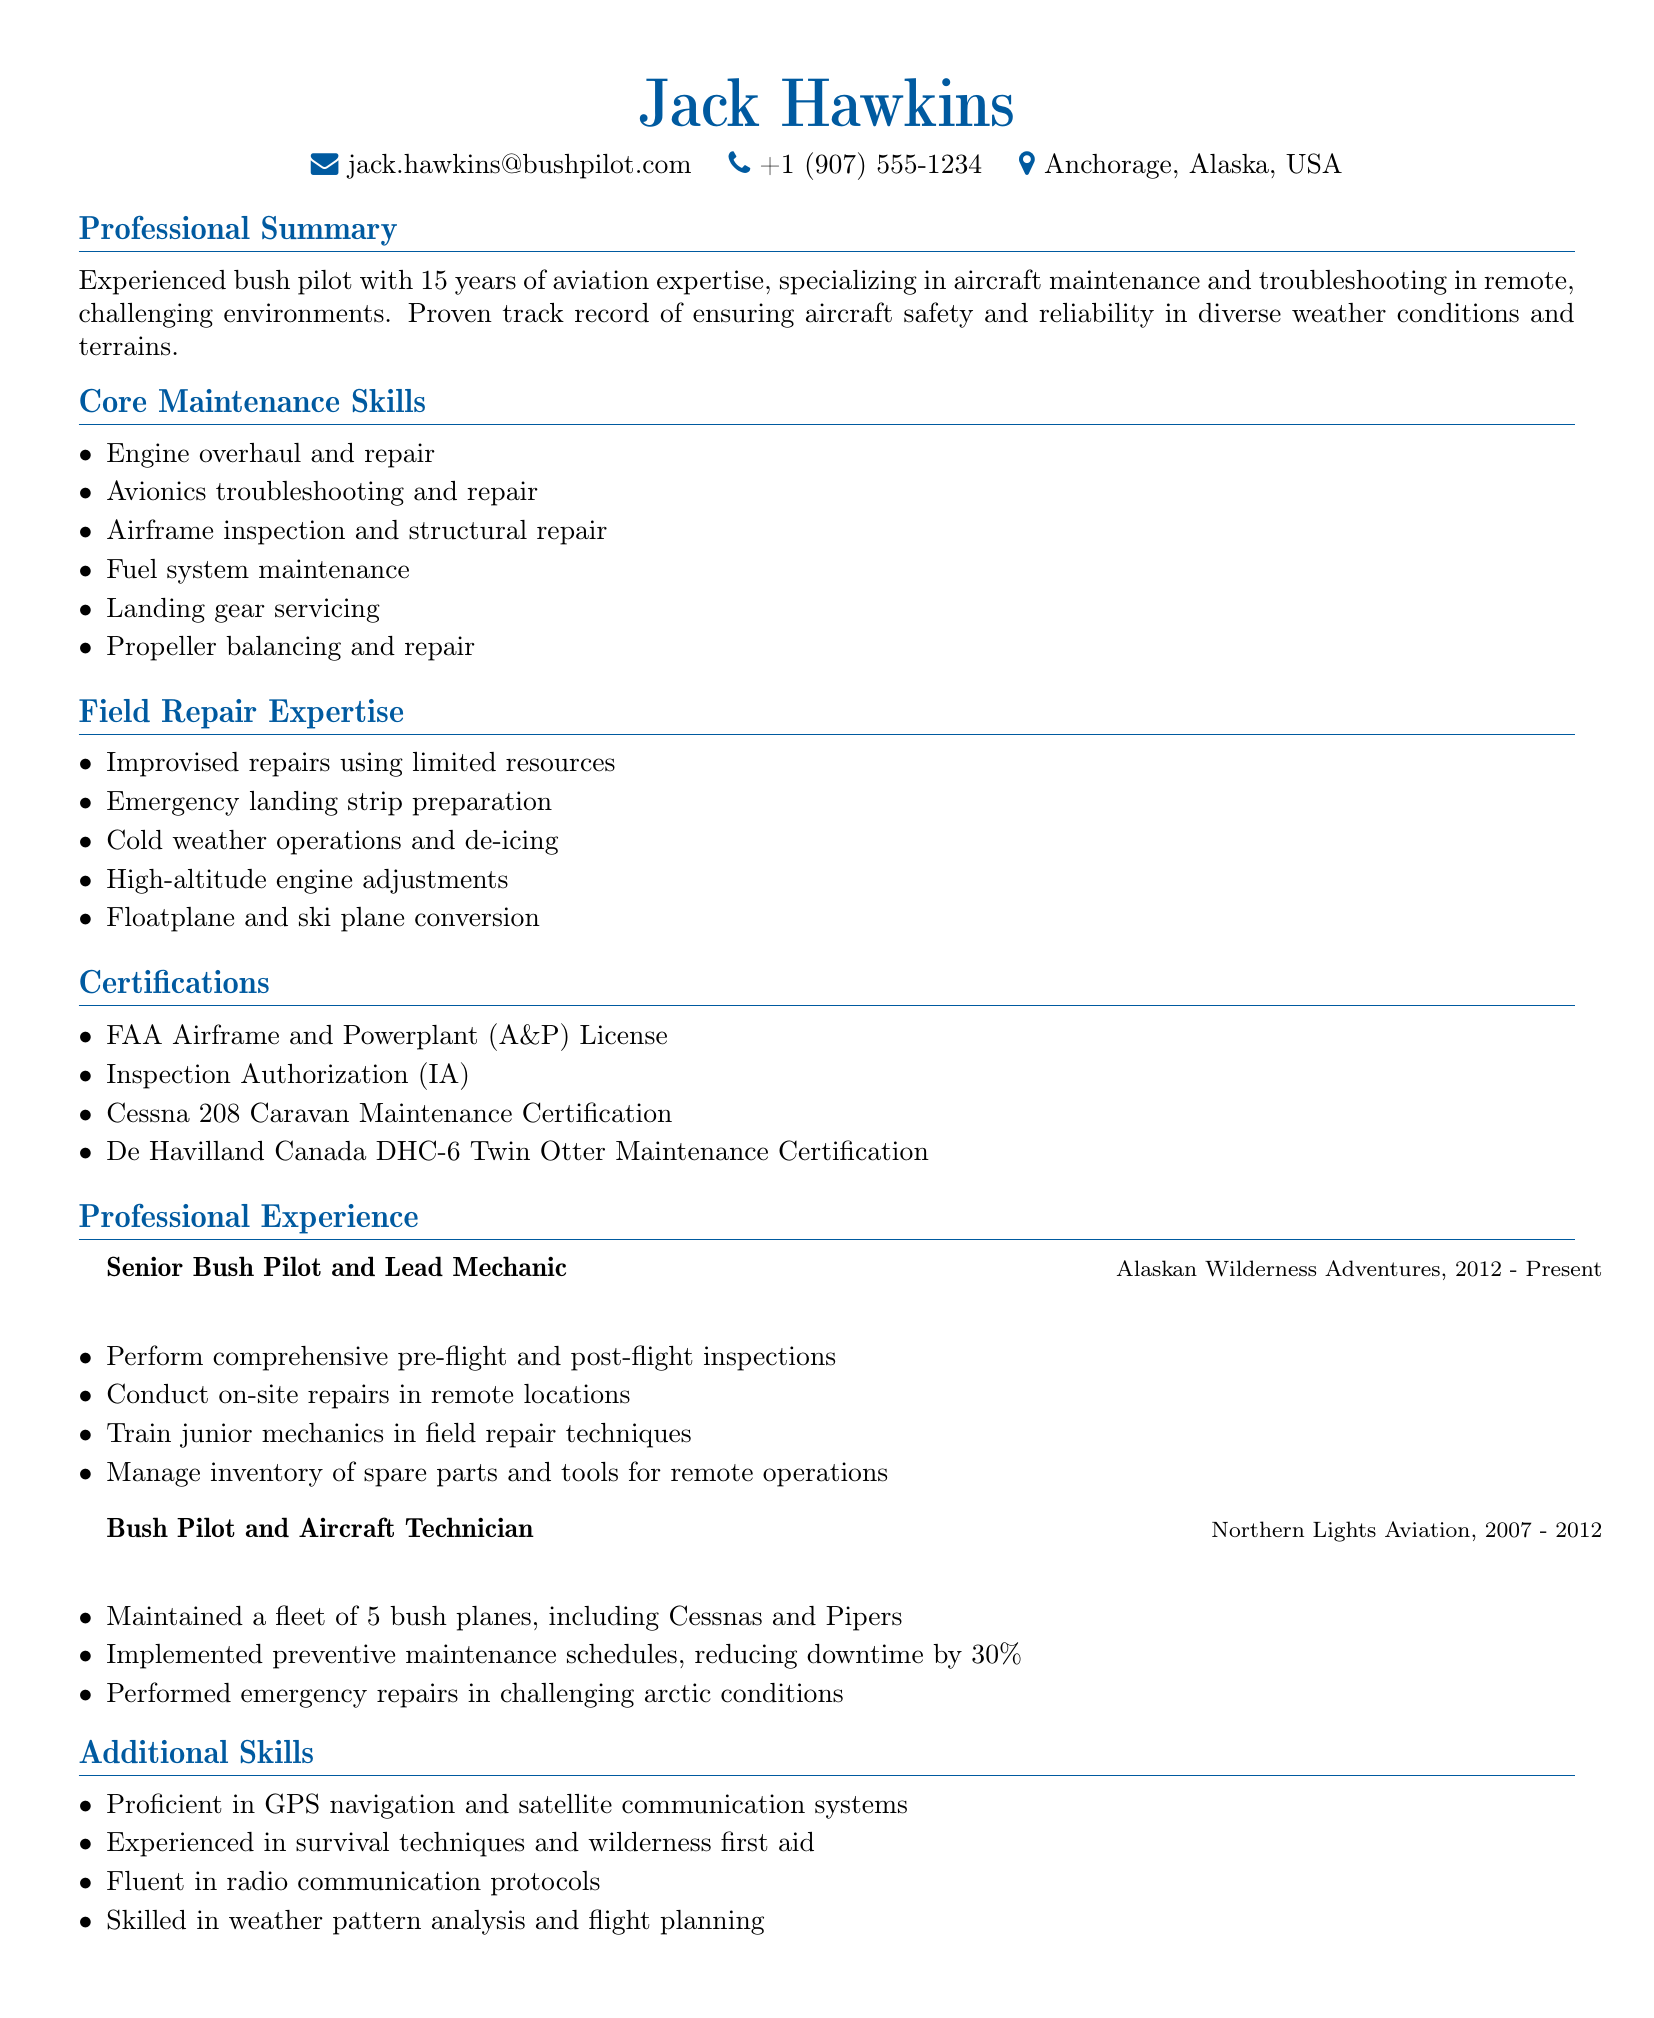What is the name of the bush pilot? The name is stated at the beginning of the document under personal information.
Answer: Jack Hawkins How many years of aviation expertise does the pilot have? This information is provided in the professional summary section of the document.
Answer: 15 years What certification is required for inspection authorization? The certification is listed under the certifications section.
Answer: Inspection Authorization (IA) What is one of the responsibilities of the Senior Bush Pilot and Lead Mechanic? Responsibilities are outlined in the professional experience section corresponding to the position listed.
Answer: Conduct on-site repairs in remote locations What major skill is associated with cold weather operations? This skill can be found under the field repair expertise section.
Answer: De-icing Which company did the pilot work for from 2007 to 2012? This company is mentioned in the professional experience section.
Answer: Northern Lights Aviation What maintenance certification is specific to the Cessna 208? The document lists relevant certifications in the certifications section.
Answer: Cessna 208 Caravan Maintenance Certification What percentage did preventive maintenance schedules reduce downtime by? This detail is provided in the responsibilities related to the pilot's prior position.
Answer: 30 percent 